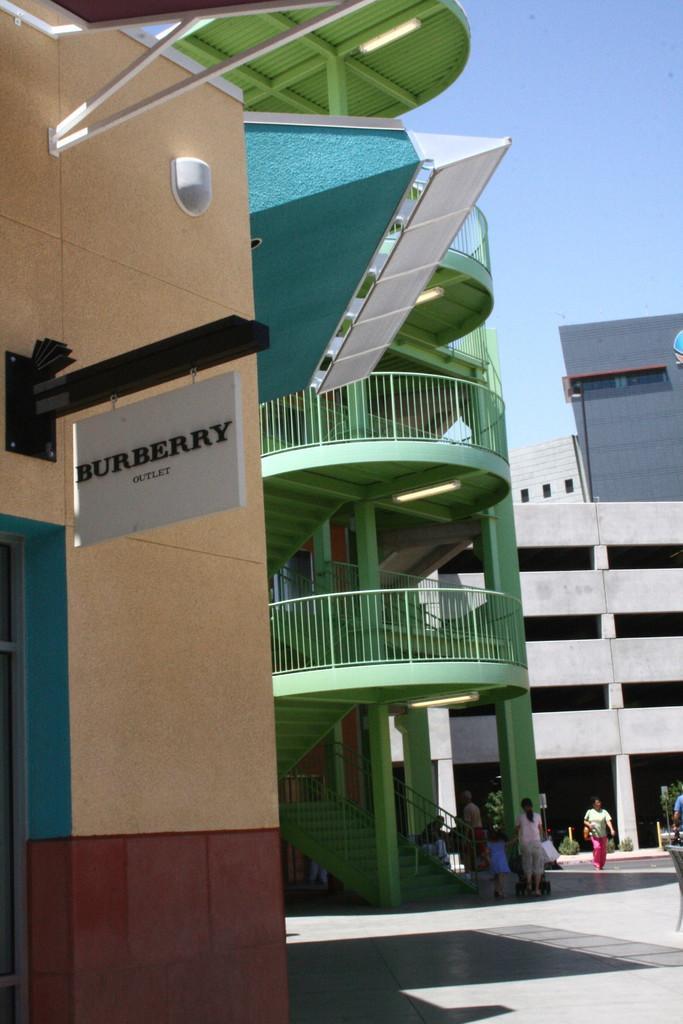How would you summarize this image in a sentence or two? In this image I can see the ground, number of people standing, few stairs, the railing, a white colored board and few buildings. In the background I can see the sky. 